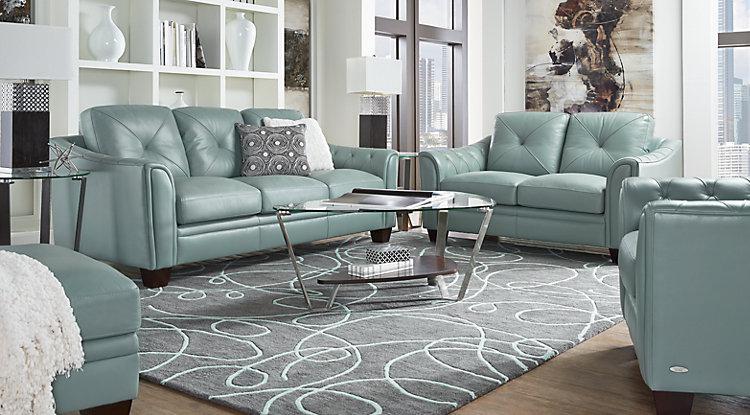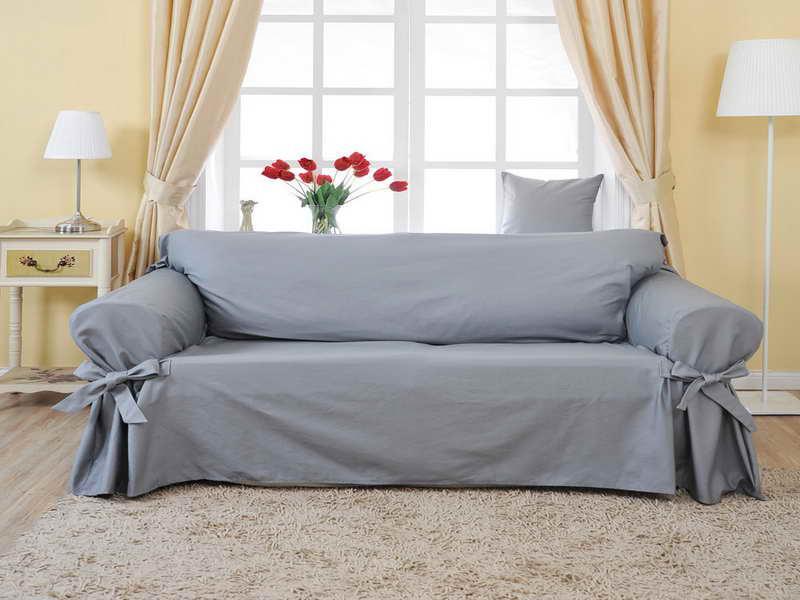The first image is the image on the left, the second image is the image on the right. Examine the images to the left and right. Is the description "There is a single table lamp with a white shade to the right of a couch in the left image." accurate? Answer yes or no. Yes. The first image is the image on the left, the second image is the image on the right. For the images shown, is this caption "The room on the left features a large printed rug, a vase filled with hot pink flowers, and an upholstered, tufted piece of furniture." true? Answer yes or no. No. 